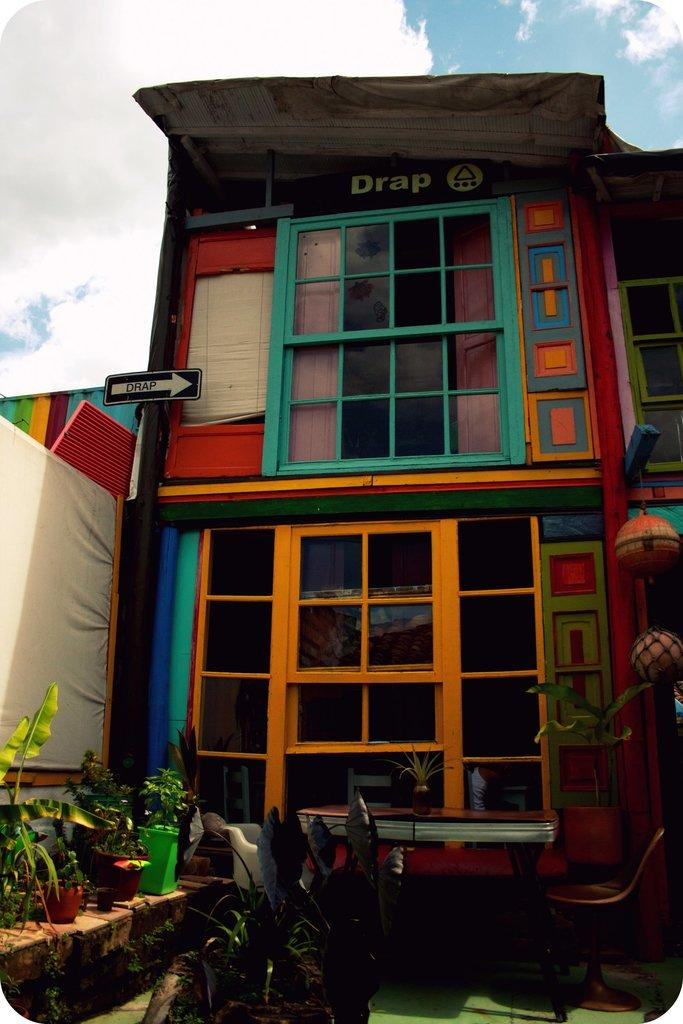What is located in the foreground of the image? There are potted plants in the foreground of the image. Where are the potted plants placed? The potted plants are on the ground. What can be seen in the background of the image? There are glass windows, sign boards, the sky, and the ground visible in the background of the image. Can you see a crow perched on the boundary in the image? There is no crow or boundary present in the image. What type of badge is being worn by the person in the image? There is no person or badge present in the image. 